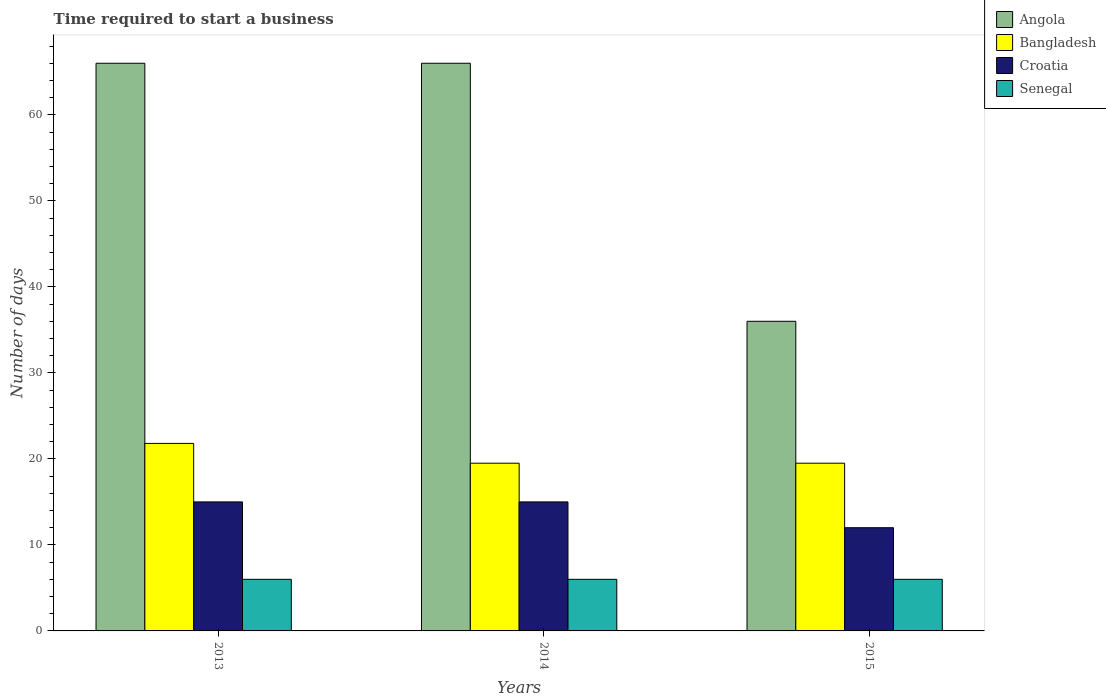Are the number of bars on each tick of the X-axis equal?
Offer a terse response. Yes. How many bars are there on the 3rd tick from the right?
Make the answer very short. 4. What is the label of the 1st group of bars from the left?
Ensure brevity in your answer.  2013. Across all years, what is the maximum number of days required to start a business in Bangladesh?
Your answer should be compact. 21.8. Across all years, what is the minimum number of days required to start a business in Croatia?
Offer a very short reply. 12. In which year was the number of days required to start a business in Angola maximum?
Your response must be concise. 2013. In which year was the number of days required to start a business in Croatia minimum?
Give a very brief answer. 2015. What is the total number of days required to start a business in Angola in the graph?
Keep it short and to the point. 168. What is the difference between the number of days required to start a business in Senegal in 2014 and that in 2015?
Provide a short and direct response. 0. What is the difference between the number of days required to start a business in Angola in 2014 and the number of days required to start a business in Senegal in 2013?
Your response must be concise. 60. In the year 2014, what is the difference between the number of days required to start a business in Bangladesh and number of days required to start a business in Angola?
Ensure brevity in your answer.  -46.5. In how many years, is the number of days required to start a business in Bangladesh greater than 54 days?
Your response must be concise. 0. What is the ratio of the number of days required to start a business in Croatia in 2013 to that in 2014?
Provide a succinct answer. 1. Is the number of days required to start a business in Bangladesh in 2014 less than that in 2015?
Offer a terse response. No. Is the difference between the number of days required to start a business in Bangladesh in 2013 and 2015 greater than the difference between the number of days required to start a business in Angola in 2013 and 2015?
Ensure brevity in your answer.  No. What is the difference between the highest and the second highest number of days required to start a business in Bangladesh?
Keep it short and to the point. 2.3. What is the difference between the highest and the lowest number of days required to start a business in Senegal?
Offer a very short reply. 0. In how many years, is the number of days required to start a business in Croatia greater than the average number of days required to start a business in Croatia taken over all years?
Your answer should be very brief. 2. Is it the case that in every year, the sum of the number of days required to start a business in Croatia and number of days required to start a business in Bangladesh is greater than the sum of number of days required to start a business in Senegal and number of days required to start a business in Angola?
Ensure brevity in your answer.  No. What does the 3rd bar from the left in 2015 represents?
Give a very brief answer. Croatia. What does the 2nd bar from the right in 2013 represents?
Your answer should be compact. Croatia. Is it the case that in every year, the sum of the number of days required to start a business in Bangladesh and number of days required to start a business in Senegal is greater than the number of days required to start a business in Angola?
Provide a short and direct response. No. What is the difference between two consecutive major ticks on the Y-axis?
Your answer should be compact. 10. Does the graph contain any zero values?
Provide a short and direct response. No. How many legend labels are there?
Your answer should be compact. 4. How are the legend labels stacked?
Provide a short and direct response. Vertical. What is the title of the graph?
Your answer should be compact. Time required to start a business. Does "Macedonia" appear as one of the legend labels in the graph?
Provide a short and direct response. No. What is the label or title of the X-axis?
Provide a succinct answer. Years. What is the label or title of the Y-axis?
Your answer should be compact. Number of days. What is the Number of days in Angola in 2013?
Your answer should be compact. 66. What is the Number of days of Bangladesh in 2013?
Offer a terse response. 21.8. What is the Number of days of Croatia in 2013?
Your response must be concise. 15. What is the Number of days of Senegal in 2013?
Your response must be concise. 6. What is the Number of days of Angola in 2014?
Your response must be concise. 66. What is the Number of days in Croatia in 2014?
Make the answer very short. 15. What is the Number of days in Angola in 2015?
Provide a succinct answer. 36. What is the Number of days of Bangladesh in 2015?
Provide a succinct answer. 19.5. What is the Number of days in Senegal in 2015?
Your answer should be very brief. 6. Across all years, what is the maximum Number of days of Angola?
Your answer should be very brief. 66. Across all years, what is the maximum Number of days of Bangladesh?
Provide a succinct answer. 21.8. Across all years, what is the minimum Number of days of Croatia?
Make the answer very short. 12. Across all years, what is the minimum Number of days in Senegal?
Your answer should be compact. 6. What is the total Number of days in Angola in the graph?
Offer a terse response. 168. What is the total Number of days in Bangladesh in the graph?
Your answer should be very brief. 60.8. What is the total Number of days in Senegal in the graph?
Your response must be concise. 18. What is the difference between the Number of days in Bangladesh in 2013 and that in 2014?
Provide a succinct answer. 2.3. What is the difference between the Number of days in Angola in 2013 and that in 2015?
Keep it short and to the point. 30. What is the difference between the Number of days in Bangladesh in 2013 and that in 2015?
Give a very brief answer. 2.3. What is the difference between the Number of days of Senegal in 2013 and that in 2015?
Make the answer very short. 0. What is the difference between the Number of days of Angola in 2014 and that in 2015?
Give a very brief answer. 30. What is the difference between the Number of days of Bangladesh in 2014 and that in 2015?
Give a very brief answer. 0. What is the difference between the Number of days of Croatia in 2014 and that in 2015?
Make the answer very short. 3. What is the difference between the Number of days in Senegal in 2014 and that in 2015?
Your response must be concise. 0. What is the difference between the Number of days in Angola in 2013 and the Number of days in Bangladesh in 2014?
Offer a terse response. 46.5. What is the difference between the Number of days of Bangladesh in 2013 and the Number of days of Croatia in 2014?
Ensure brevity in your answer.  6.8. What is the difference between the Number of days in Croatia in 2013 and the Number of days in Senegal in 2014?
Keep it short and to the point. 9. What is the difference between the Number of days of Angola in 2013 and the Number of days of Bangladesh in 2015?
Make the answer very short. 46.5. What is the difference between the Number of days in Bangladesh in 2013 and the Number of days in Croatia in 2015?
Your answer should be very brief. 9.8. What is the difference between the Number of days in Angola in 2014 and the Number of days in Bangladesh in 2015?
Make the answer very short. 46.5. What is the difference between the Number of days in Angola in 2014 and the Number of days in Senegal in 2015?
Provide a short and direct response. 60. What is the difference between the Number of days in Bangladesh in 2014 and the Number of days in Croatia in 2015?
Offer a terse response. 7.5. What is the difference between the Number of days in Croatia in 2014 and the Number of days in Senegal in 2015?
Your answer should be very brief. 9. What is the average Number of days of Bangladesh per year?
Offer a very short reply. 20.27. What is the average Number of days in Croatia per year?
Offer a terse response. 14. What is the average Number of days in Senegal per year?
Offer a terse response. 6. In the year 2013, what is the difference between the Number of days of Angola and Number of days of Bangladesh?
Your response must be concise. 44.2. In the year 2013, what is the difference between the Number of days of Angola and Number of days of Senegal?
Keep it short and to the point. 60. In the year 2013, what is the difference between the Number of days of Bangladesh and Number of days of Senegal?
Provide a succinct answer. 15.8. In the year 2013, what is the difference between the Number of days of Croatia and Number of days of Senegal?
Offer a terse response. 9. In the year 2014, what is the difference between the Number of days of Angola and Number of days of Bangladesh?
Give a very brief answer. 46.5. In the year 2014, what is the difference between the Number of days of Angola and Number of days of Croatia?
Your response must be concise. 51. In the year 2014, what is the difference between the Number of days of Bangladesh and Number of days of Croatia?
Offer a terse response. 4.5. In the year 2014, what is the difference between the Number of days in Bangladesh and Number of days in Senegal?
Give a very brief answer. 13.5. In the year 2014, what is the difference between the Number of days in Croatia and Number of days in Senegal?
Make the answer very short. 9. In the year 2015, what is the difference between the Number of days in Angola and Number of days in Bangladesh?
Give a very brief answer. 16.5. In the year 2015, what is the difference between the Number of days in Angola and Number of days in Croatia?
Provide a succinct answer. 24. In the year 2015, what is the difference between the Number of days of Bangladesh and Number of days of Senegal?
Offer a terse response. 13.5. In the year 2015, what is the difference between the Number of days in Croatia and Number of days in Senegal?
Provide a succinct answer. 6. What is the ratio of the Number of days of Bangladesh in 2013 to that in 2014?
Offer a terse response. 1.12. What is the ratio of the Number of days in Senegal in 2013 to that in 2014?
Provide a short and direct response. 1. What is the ratio of the Number of days of Angola in 2013 to that in 2015?
Keep it short and to the point. 1.83. What is the ratio of the Number of days in Bangladesh in 2013 to that in 2015?
Make the answer very short. 1.12. What is the ratio of the Number of days in Croatia in 2013 to that in 2015?
Keep it short and to the point. 1.25. What is the ratio of the Number of days in Senegal in 2013 to that in 2015?
Your response must be concise. 1. What is the ratio of the Number of days of Angola in 2014 to that in 2015?
Ensure brevity in your answer.  1.83. What is the ratio of the Number of days of Bangladesh in 2014 to that in 2015?
Your response must be concise. 1. What is the difference between the highest and the second highest Number of days in Angola?
Offer a terse response. 0. What is the difference between the highest and the second highest Number of days of Croatia?
Your answer should be compact. 0. What is the difference between the highest and the second highest Number of days of Senegal?
Your answer should be compact. 0. What is the difference between the highest and the lowest Number of days of Angola?
Offer a terse response. 30. What is the difference between the highest and the lowest Number of days in Croatia?
Ensure brevity in your answer.  3. What is the difference between the highest and the lowest Number of days of Senegal?
Make the answer very short. 0. 